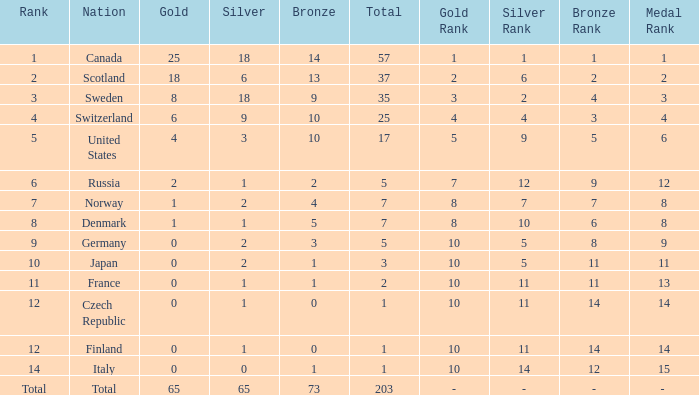Write the full table. {'header': ['Rank', 'Nation', 'Gold', 'Silver', 'Bronze', 'Total', 'Gold Rank', 'Silver Rank', 'Bronze Rank', 'Medal Rank'], 'rows': [['1', 'Canada', '25', '18', '14', '57', '1', '1', '1', '1'], ['2', 'Scotland', '18', '6', '13', '37', '2', '6', '2', '2'], ['3', 'Sweden', '8', '18', '9', '35', '3', '2', '4', '3'], ['4', 'Switzerland', '6', '9', '10', '25', '4', '4', '3', '4'], ['5', 'United States', '4', '3', '10', '17', '5', '9', '5', '6'], ['6', 'Russia', '2', '1', '2', '5', '7', '12', '9', '12'], ['7', 'Norway', '1', '2', '4', '7', '8', '7', '7', '8'], ['8', 'Denmark', '1', '1', '5', '7', '8', '10', '6', '8'], ['9', 'Germany', '0', '2', '3', '5', '10', '5', '8', '9'], ['10', 'Japan', '0', '2', '1', '3', '10', '5', '11', '11'], ['11', 'France', '0', '1', '1', '2', '10', '11', '11', '13'], ['12', 'Czech Republic', '0', '1', '0', '1', '10', '11', '14', '14'], ['12', 'Finland', '0', '1', '0', '1', '10', '11', '14', '14'], ['14', 'Italy', '0', '0', '1', '1', '10', '14', '12', '15'], ['Total', 'Total', '65', '65', '73', '203', '-', '-', '-', '- ']]} What is the lowest total when the rank is 14 and the gold medals is larger than 0? None. 